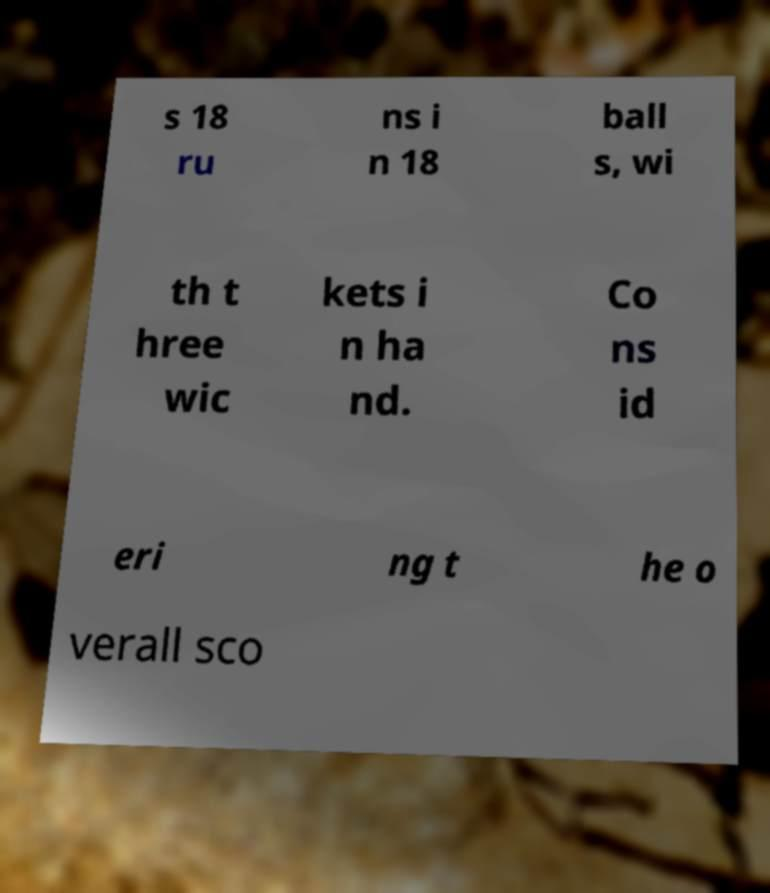Could you assist in decoding the text presented in this image and type it out clearly? s 18 ru ns i n 18 ball s, wi th t hree wic kets i n ha nd. Co ns id eri ng t he o verall sco 